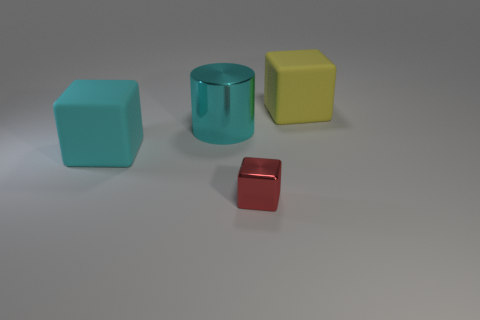Can you tell me what materials these objects are made from? From the image, the objects seem to have different textures. The red object has a reflective surface that suggests it's metallic, while the light blue, yellow, and teal objects appear to have a matte finish, possibly indicating they are made of plastic. 